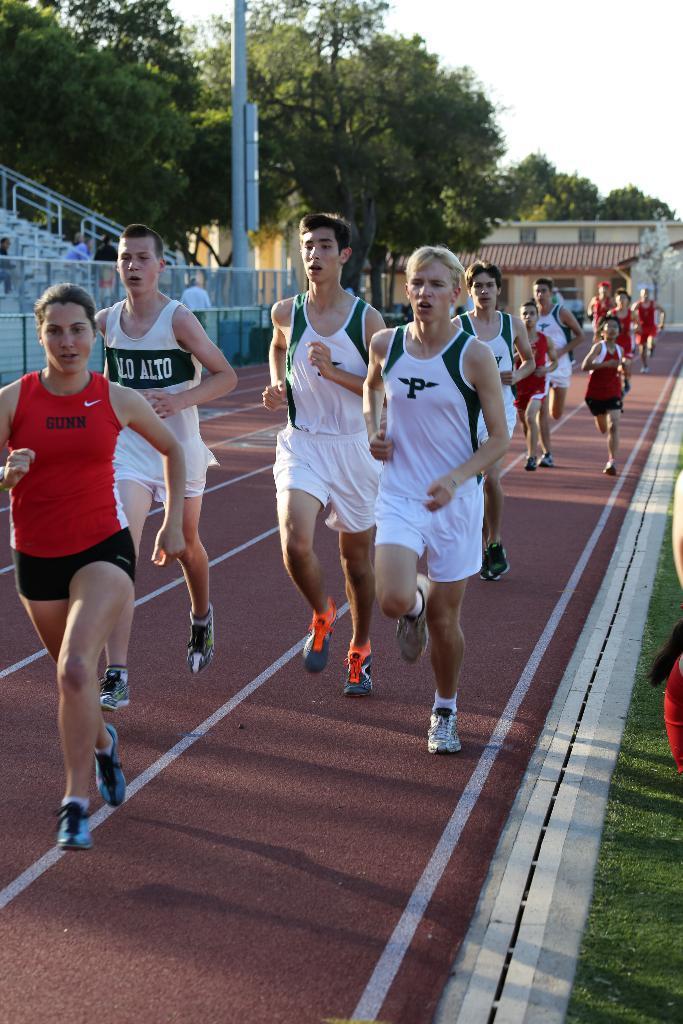Could you give a brief overview of what you see in this image? In the middle of the image few people are running. Behind them there is a fencing and poles and buildings and trees. In the bottom right corner of the image there is grass. 